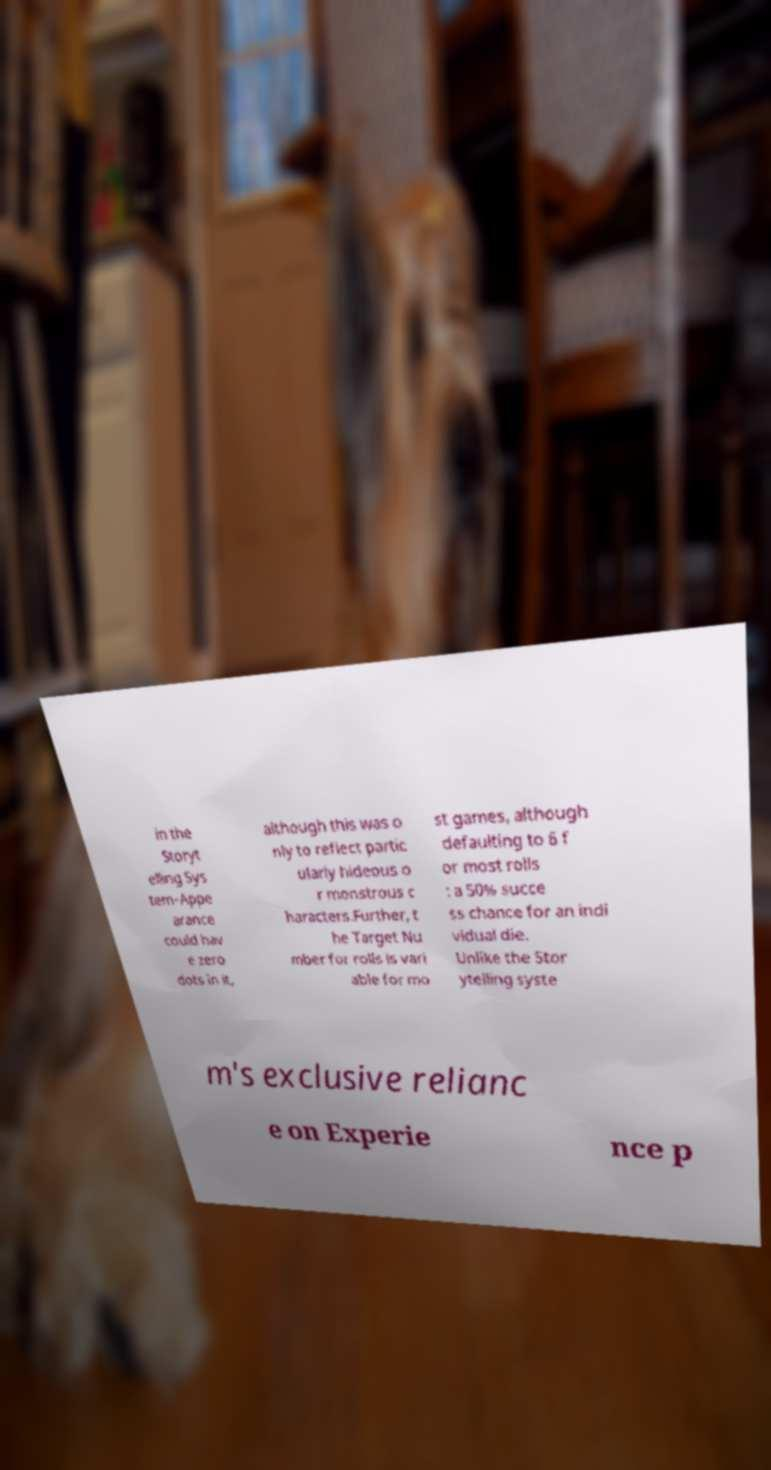For documentation purposes, I need the text within this image transcribed. Could you provide that? in the Storyt elling Sys tem–Appe arance could hav e zero dots in it, although this was o nly to reflect partic ularly hideous o r monstrous c haracters.Further, t he Target Nu mber for rolls is vari able for mo st games, although defaulting to 6 f or most rolls : a 50% succe ss chance for an indi vidual die. Unlike the Stor ytelling syste m's exclusive relianc e on Experie nce p 